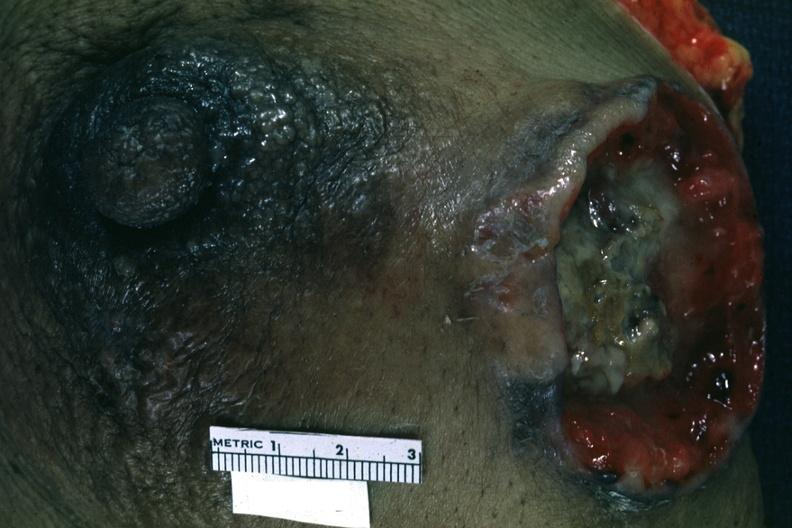where is this area in the body?
Answer the question using a single word or phrase. Breast 